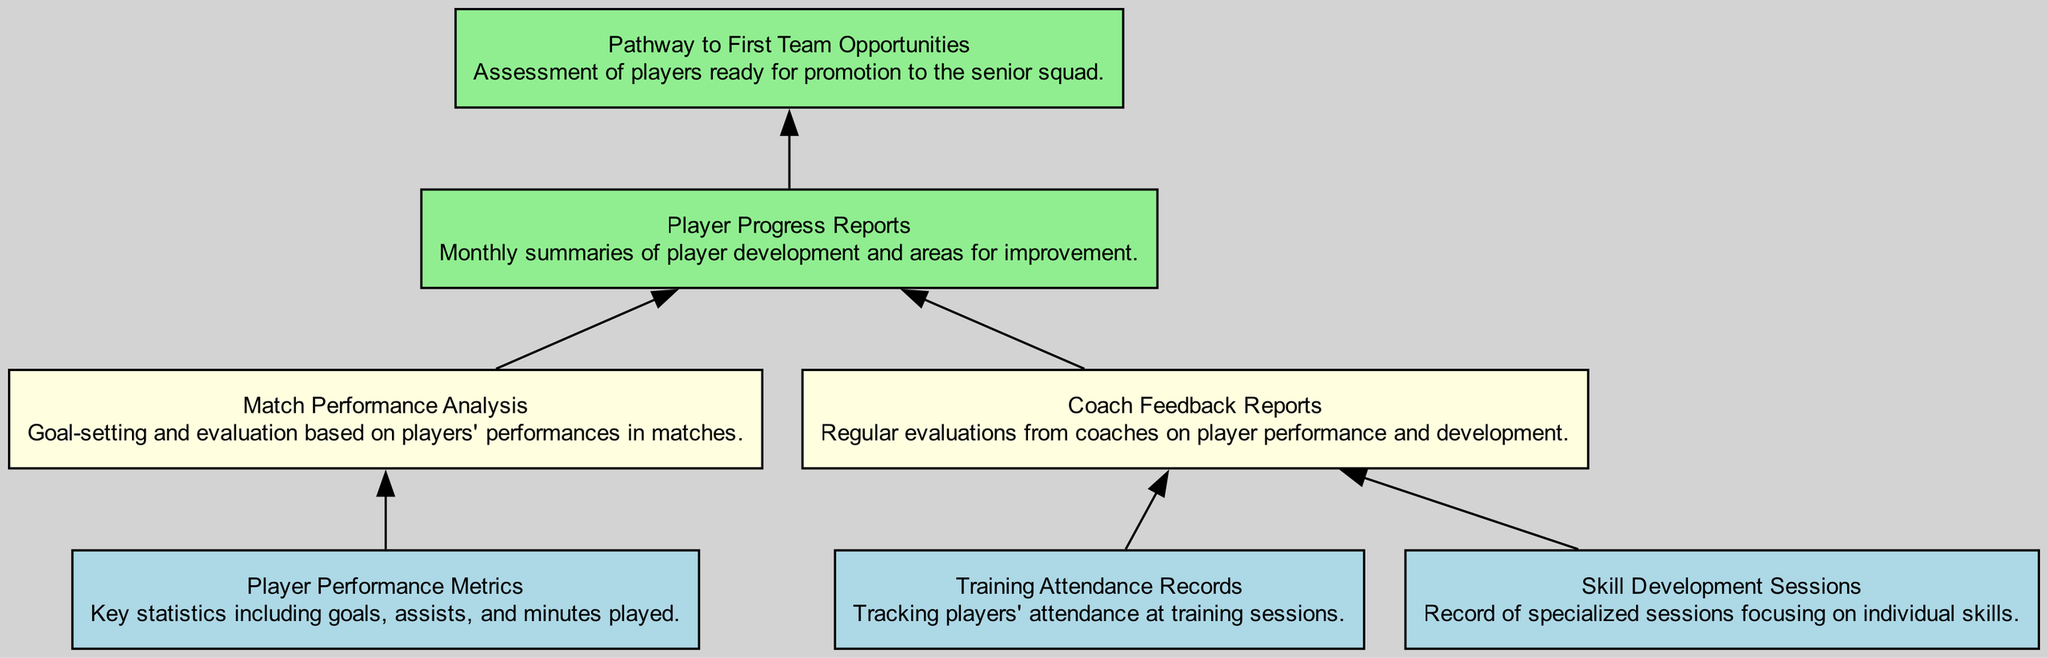What are the three input types in the diagram? The diagram features the input types: "Player Performance Metrics," "Training Attendance Records," and "Skill Development Sessions." Each of these elements serves as foundational metrics or records input into the system.
Answer: Player Performance Metrics, Training Attendance Records, Skill Development Sessions What type of output is generated after "Player Progress Reports"? The diagram shows that after "Player Progress Reports," the next output is "Pathway to First Team Opportunities," indicating that progress reports lead to an assessment for potential promotion to the senior squad.
Answer: Pathway to First Team Opportunities How many process nodes are present in the diagram? Reviewing the diagram, there are three process nodes: "Coach Feedback Reports," "Match Performance Analysis," and "Player Progress Reports." These nodes represent the stages of processing the input data before generating outputs.
Answer: 3 Which input connects to "Coach Feedback Reports"? The diagram illustrates that both "Training Attendance Records" and "Skill Development Sessions" lead into "Coach Feedback Reports," meaning these inputs are used for evaluating player performance and skill development.
Answer: Training Attendance Records, Skill Development Sessions What is the main purpose of "Match Performance Analysis"? Examining the diagram, "Match Performance Analysis" focuses on goal-setting and evaluation based on players' performances in matches, which is key for understanding a player's contribution during games and overall progress.
Answer: Goal-setting and evaluation Which input type is directly linked to "Match Performance Analysis"? According to the diagram, "Player Performance Metrics" is the input that feeds directly into "Match Performance Analysis," providing essential statistics to evaluate players' match efforts such as goals and assists.
Answer: Player Performance Metrics What describes the relationship between "Coach Feedback Reports" and "Player Progress Reports"? The diagram indicates that "Coach Feedback Reports" provide evaluations which are then processed to create "Player Progress Reports." This signifies that the feedback from coaches is instrumental in developing progress reports for players.
Answer: Evaluations leading to reports How many edges connect the input nodes to process nodes? In the diagram, there are five edges connecting the input nodes to the process nodes. Specifically, they connect "Player Performance Metrics" to "Match Performance Analysis," "Training Attendance Records" and "Skill Development Sessions" to "Coach Feedback Reports," and both "Match Performance Analysis" and "Coach Feedback Reports" to "Player Progress Reports."
Answer: 5 